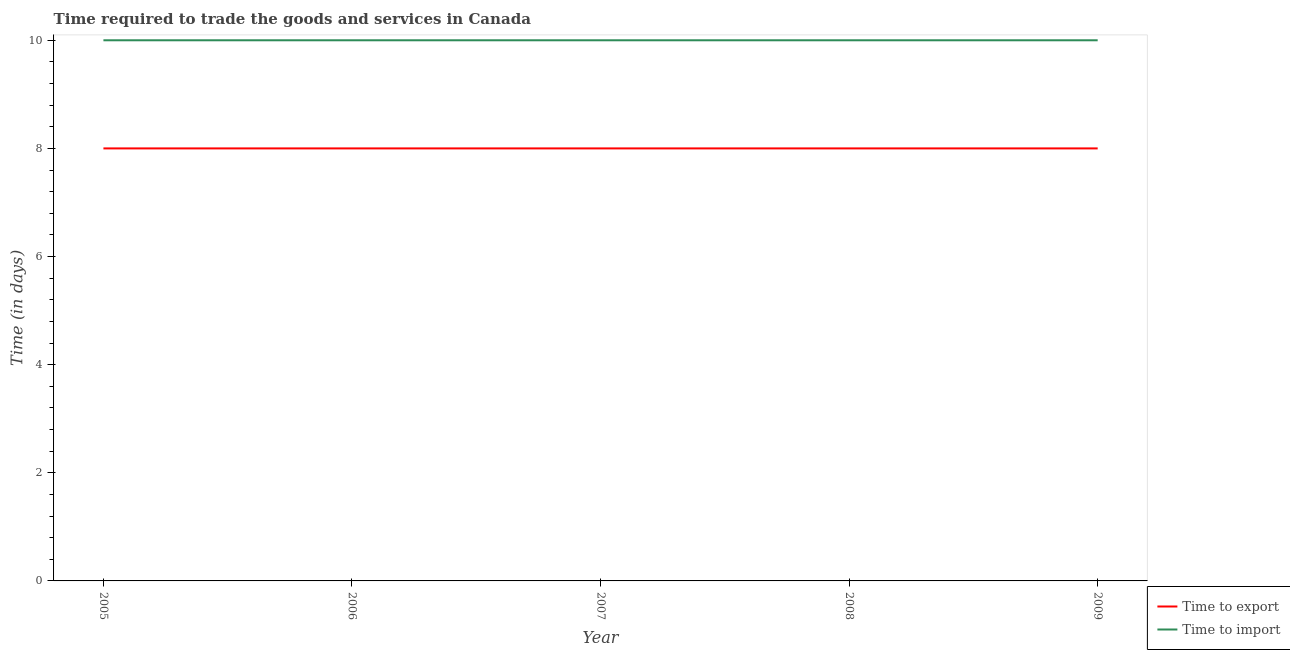Does the line corresponding to time to export intersect with the line corresponding to time to import?
Ensure brevity in your answer.  No. What is the time to export in 2006?
Offer a terse response. 8. Across all years, what is the maximum time to import?
Offer a very short reply. 10. Across all years, what is the minimum time to export?
Ensure brevity in your answer.  8. In which year was the time to export maximum?
Your response must be concise. 2005. What is the total time to import in the graph?
Your answer should be compact. 50. What is the difference between the time to import in 2006 and the time to export in 2005?
Provide a short and direct response. 2. In the year 2006, what is the difference between the time to import and time to export?
Your response must be concise. 2. Is the difference between the time to export in 2005 and 2008 greater than the difference between the time to import in 2005 and 2008?
Provide a succinct answer. No. What is the difference between the highest and the second highest time to export?
Your answer should be very brief. 0. In how many years, is the time to import greater than the average time to import taken over all years?
Give a very brief answer. 0. Does the time to import monotonically increase over the years?
Provide a short and direct response. No. How many years are there in the graph?
Your response must be concise. 5. Are the values on the major ticks of Y-axis written in scientific E-notation?
Provide a succinct answer. No. Does the graph contain grids?
Your answer should be compact. No. Where does the legend appear in the graph?
Make the answer very short. Bottom right. How many legend labels are there?
Make the answer very short. 2. How are the legend labels stacked?
Offer a very short reply. Vertical. What is the title of the graph?
Your answer should be very brief. Time required to trade the goods and services in Canada. Does "Secondary Education" appear as one of the legend labels in the graph?
Offer a very short reply. No. What is the label or title of the Y-axis?
Your answer should be very brief. Time (in days). What is the Time (in days) in Time to export in 2005?
Offer a very short reply. 8. What is the Time (in days) of Time to import in 2005?
Give a very brief answer. 10. Across all years, what is the maximum Time (in days) of Time to import?
Ensure brevity in your answer.  10. Across all years, what is the minimum Time (in days) of Time to export?
Offer a terse response. 8. What is the total Time (in days) of Time to export in the graph?
Keep it short and to the point. 40. What is the difference between the Time (in days) of Time to export in 2005 and that in 2008?
Provide a short and direct response. 0. What is the difference between the Time (in days) of Time to export in 2005 and that in 2009?
Your answer should be very brief. 0. What is the difference between the Time (in days) in Time to import in 2005 and that in 2009?
Your response must be concise. 0. What is the difference between the Time (in days) in Time to import in 2006 and that in 2007?
Offer a very short reply. 0. What is the difference between the Time (in days) in Time to export in 2006 and that in 2008?
Provide a short and direct response. 0. What is the difference between the Time (in days) in Time to export in 2006 and that in 2009?
Provide a succinct answer. 0. What is the difference between the Time (in days) in Time to export in 2007 and that in 2008?
Provide a succinct answer. 0. What is the difference between the Time (in days) in Time to import in 2007 and that in 2008?
Your answer should be very brief. 0. What is the difference between the Time (in days) in Time to export in 2007 and that in 2009?
Provide a short and direct response. 0. What is the difference between the Time (in days) in Time to export in 2008 and that in 2009?
Provide a short and direct response. 0. What is the difference between the Time (in days) of Time to import in 2008 and that in 2009?
Provide a succinct answer. 0. What is the difference between the Time (in days) of Time to export in 2005 and the Time (in days) of Time to import in 2006?
Provide a short and direct response. -2. What is the difference between the Time (in days) in Time to export in 2005 and the Time (in days) in Time to import in 2007?
Your response must be concise. -2. What is the difference between the Time (in days) of Time to export in 2005 and the Time (in days) of Time to import in 2009?
Your response must be concise. -2. What is the difference between the Time (in days) in Time to export in 2006 and the Time (in days) in Time to import in 2008?
Offer a very short reply. -2. What is the difference between the Time (in days) of Time to export in 2008 and the Time (in days) of Time to import in 2009?
Offer a terse response. -2. What is the average Time (in days) in Time to export per year?
Provide a short and direct response. 8. What is the average Time (in days) in Time to import per year?
Offer a terse response. 10. In the year 2005, what is the difference between the Time (in days) in Time to export and Time (in days) in Time to import?
Provide a short and direct response. -2. In the year 2007, what is the difference between the Time (in days) in Time to export and Time (in days) in Time to import?
Offer a very short reply. -2. What is the ratio of the Time (in days) in Time to export in 2005 to that in 2007?
Your answer should be compact. 1. What is the ratio of the Time (in days) in Time to import in 2005 to that in 2007?
Keep it short and to the point. 1. What is the ratio of the Time (in days) of Time to export in 2005 to that in 2008?
Your answer should be compact. 1. What is the ratio of the Time (in days) in Time to export in 2006 to that in 2008?
Your answer should be compact. 1. What is the ratio of the Time (in days) in Time to export in 2006 to that in 2009?
Provide a succinct answer. 1. What is the ratio of the Time (in days) of Time to import in 2006 to that in 2009?
Your answer should be compact. 1. What is the ratio of the Time (in days) of Time to import in 2007 to that in 2008?
Provide a short and direct response. 1. What is the difference between the highest and the lowest Time (in days) in Time to export?
Provide a short and direct response. 0. 